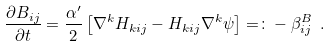Convert formula to latex. <formula><loc_0><loc_0><loc_500><loc_500>\frac { \partial B _ { i j } } { \partial t } = \frac { \alpha ^ { \prime } } { 2 } \left [ \nabla ^ { k } H _ { k i j } - H _ { k i j } \nabla ^ { k } \psi \right ] = \colon - \beta ^ { B } _ { i j } \ .</formula> 